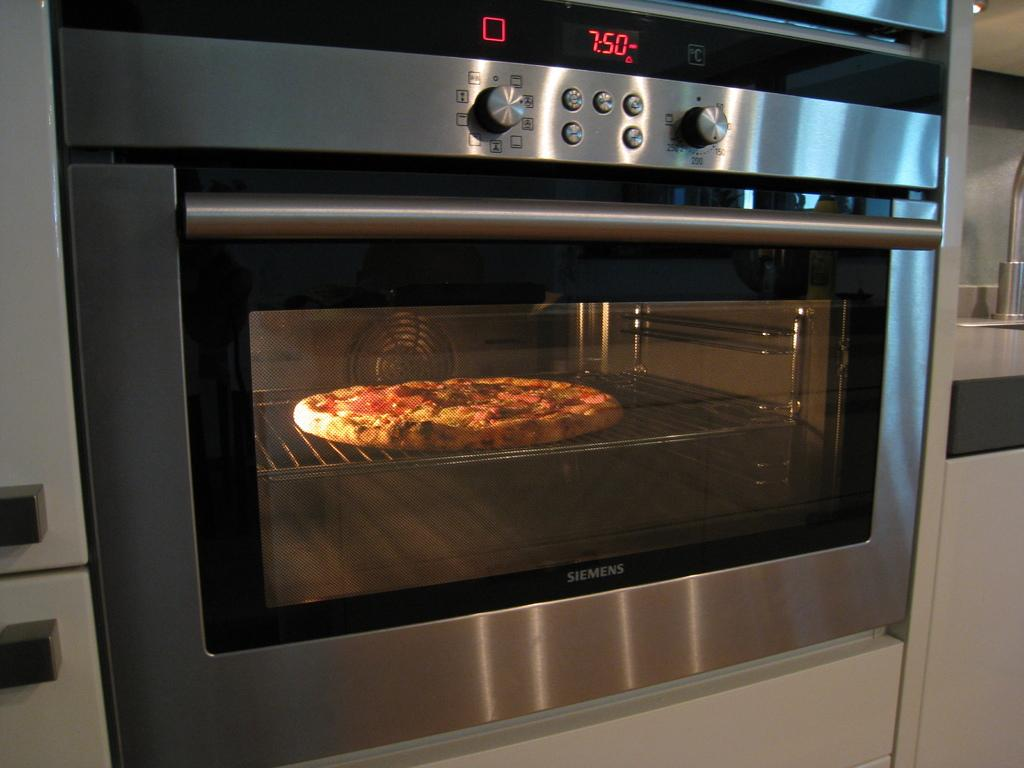<image>
Share a concise interpretation of the image provided. a pizza baking in the oven with digital numbers 750 in red on it. 